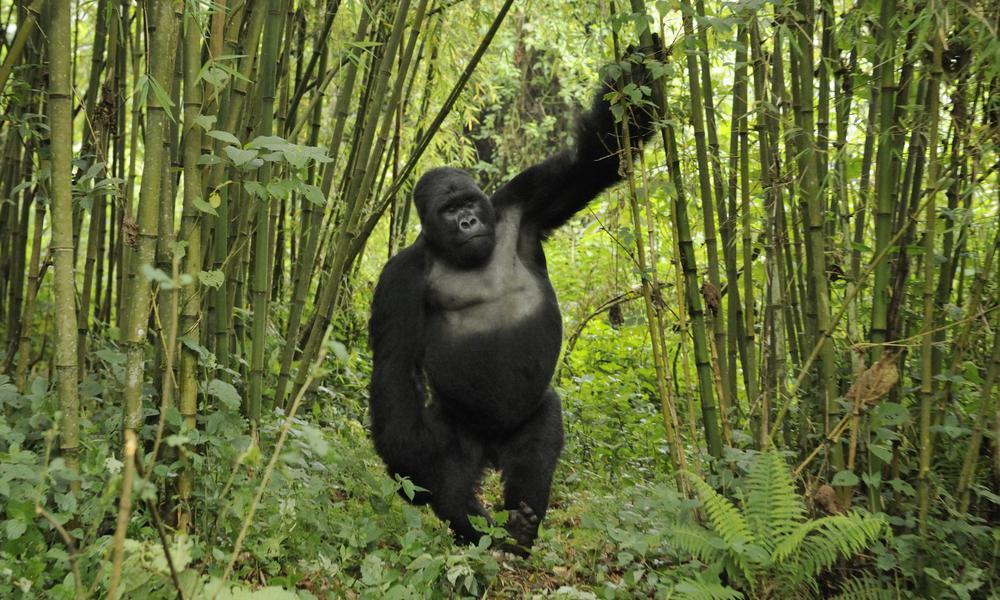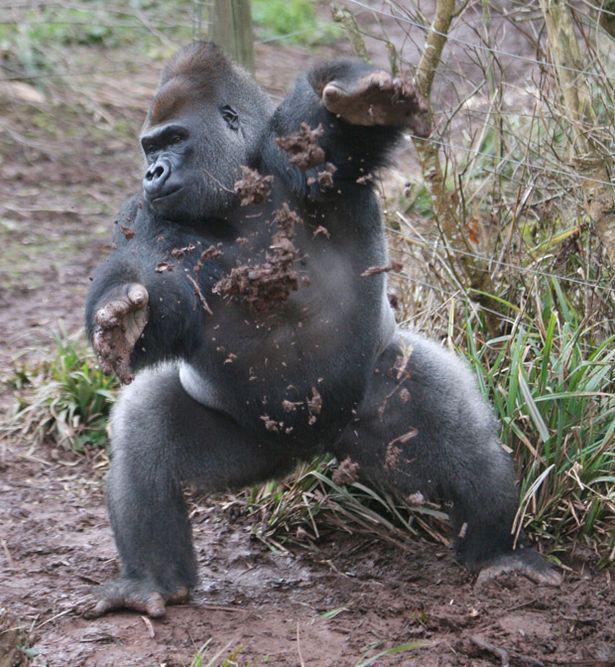The first image is the image on the left, the second image is the image on the right. Considering the images on both sides, is "An image shows one man in a scene with a dark-haired ape." valid? Answer yes or no. No. The first image is the image on the left, the second image is the image on the right. Considering the images on both sides, is "Each gorilla is standing on at least two legs." valid? Answer yes or no. Yes. 